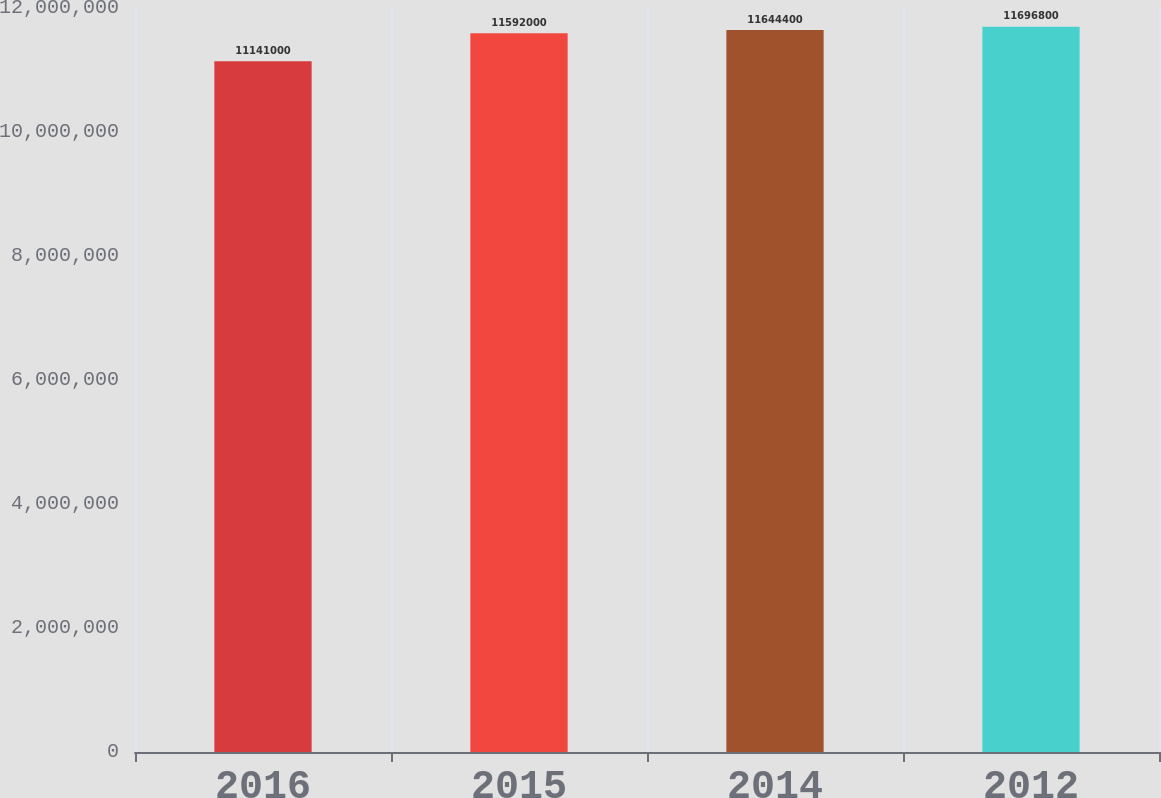Convert chart. <chart><loc_0><loc_0><loc_500><loc_500><bar_chart><fcel>2016<fcel>2015<fcel>2014<fcel>2012<nl><fcel>1.1141e+07<fcel>1.1592e+07<fcel>1.16444e+07<fcel>1.16968e+07<nl></chart> 